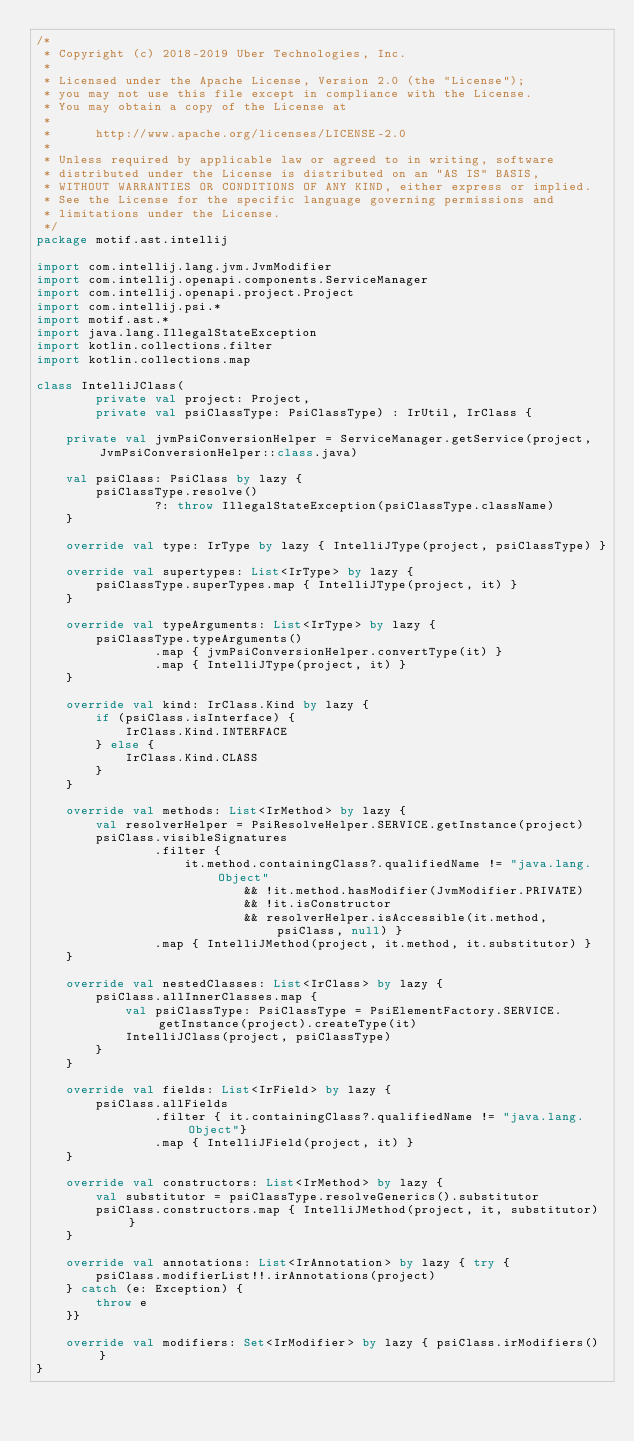<code> <loc_0><loc_0><loc_500><loc_500><_Kotlin_>/*
 * Copyright (c) 2018-2019 Uber Technologies, Inc.
 *
 * Licensed under the Apache License, Version 2.0 (the "License");
 * you may not use this file except in compliance with the License.
 * You may obtain a copy of the License at
 *
 *      http://www.apache.org/licenses/LICENSE-2.0
 *
 * Unless required by applicable law or agreed to in writing, software
 * distributed under the License is distributed on an "AS IS" BASIS,
 * WITHOUT WARRANTIES OR CONDITIONS OF ANY KIND, either express or implied.
 * See the License for the specific language governing permissions and
 * limitations under the License.
 */
package motif.ast.intellij

import com.intellij.lang.jvm.JvmModifier
import com.intellij.openapi.components.ServiceManager
import com.intellij.openapi.project.Project
import com.intellij.psi.*
import motif.ast.*
import java.lang.IllegalStateException
import kotlin.collections.filter
import kotlin.collections.map

class IntelliJClass(
        private val project: Project,
        private val psiClassType: PsiClassType) : IrUtil, IrClass {

    private val jvmPsiConversionHelper = ServiceManager.getService(project, JvmPsiConversionHelper::class.java)

    val psiClass: PsiClass by lazy {
        psiClassType.resolve()
                ?: throw IllegalStateException(psiClassType.className)
    }

    override val type: IrType by lazy { IntelliJType(project, psiClassType) }

    override val supertypes: List<IrType> by lazy {
        psiClassType.superTypes.map { IntelliJType(project, it) }
    }

    override val typeArguments: List<IrType> by lazy {
        psiClassType.typeArguments()
                .map { jvmPsiConversionHelper.convertType(it) }
                .map { IntelliJType(project, it) }
    }

    override val kind: IrClass.Kind by lazy {
        if (psiClass.isInterface) {
            IrClass.Kind.INTERFACE
        } else {
            IrClass.Kind.CLASS
        }
    }

    override val methods: List<IrMethod> by lazy {
        val resolverHelper = PsiResolveHelper.SERVICE.getInstance(project)
        psiClass.visibleSignatures
                .filter {
                    it.method.containingClass?.qualifiedName != "java.lang.Object"
                            && !it.method.hasModifier(JvmModifier.PRIVATE)
                            && !it.isConstructor
                            && resolverHelper.isAccessible(it.method, psiClass, null) }
                .map { IntelliJMethod(project, it.method, it.substitutor) }
    }

    override val nestedClasses: List<IrClass> by lazy {
        psiClass.allInnerClasses.map {
            val psiClassType: PsiClassType = PsiElementFactory.SERVICE.getInstance(project).createType(it)
            IntelliJClass(project, psiClassType)
        }
    }

    override val fields: List<IrField> by lazy {
        psiClass.allFields
                .filter { it.containingClass?.qualifiedName != "java.lang.Object"}
                .map { IntelliJField(project, it) }
    }

    override val constructors: List<IrMethod> by lazy {
        val substitutor = psiClassType.resolveGenerics().substitutor
        psiClass.constructors.map { IntelliJMethod(project, it, substitutor) }
    }

    override val annotations: List<IrAnnotation> by lazy { try {
        psiClass.modifierList!!.irAnnotations(project)
    } catch (e: Exception) {
        throw e
    }}

    override val modifiers: Set<IrModifier> by lazy { psiClass.irModifiers() }
}
</code> 